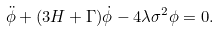<formula> <loc_0><loc_0><loc_500><loc_500>\ddot { \phi } + ( 3 H + \Gamma ) \dot { \phi } - 4 \lambda \sigma ^ { 2 } \phi = 0 .</formula> 